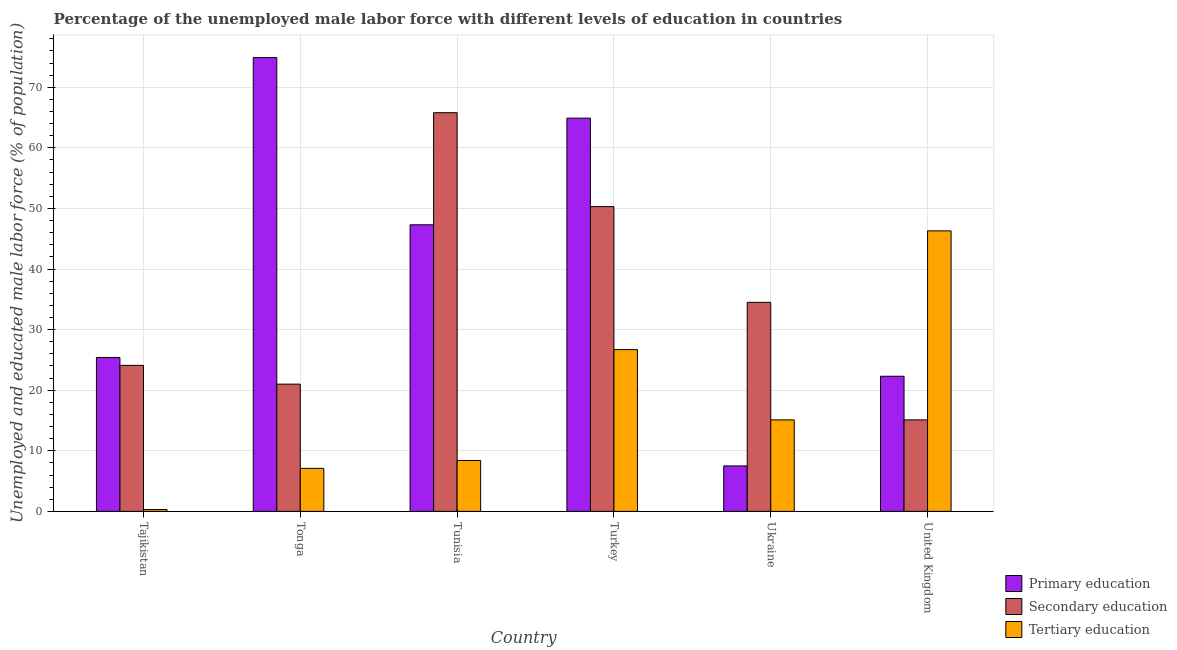How many groups of bars are there?
Your answer should be very brief. 6. Are the number of bars per tick equal to the number of legend labels?
Offer a very short reply. Yes. What is the label of the 4th group of bars from the left?
Ensure brevity in your answer.  Turkey. What is the percentage of male labor force who received primary education in Turkey?
Provide a succinct answer. 64.9. Across all countries, what is the maximum percentage of male labor force who received primary education?
Ensure brevity in your answer.  74.9. Across all countries, what is the minimum percentage of male labor force who received secondary education?
Offer a very short reply. 15.1. In which country was the percentage of male labor force who received tertiary education maximum?
Give a very brief answer. United Kingdom. In which country was the percentage of male labor force who received primary education minimum?
Ensure brevity in your answer.  Ukraine. What is the total percentage of male labor force who received primary education in the graph?
Provide a succinct answer. 242.3. What is the difference between the percentage of male labor force who received primary education in Tonga and that in United Kingdom?
Your answer should be compact. 52.6. What is the difference between the percentage of male labor force who received secondary education in Tunisia and the percentage of male labor force who received primary education in Tonga?
Provide a short and direct response. -9.1. What is the average percentage of male labor force who received primary education per country?
Provide a short and direct response. 40.38. What is the difference between the percentage of male labor force who received tertiary education and percentage of male labor force who received secondary education in Tonga?
Your answer should be very brief. -13.9. In how many countries, is the percentage of male labor force who received primary education greater than 2 %?
Provide a short and direct response. 6. What is the ratio of the percentage of male labor force who received secondary education in Tajikistan to that in Tunisia?
Your answer should be very brief. 0.37. Is the difference between the percentage of male labor force who received primary education in Turkey and United Kingdom greater than the difference between the percentage of male labor force who received tertiary education in Turkey and United Kingdom?
Offer a very short reply. Yes. What is the difference between the highest and the second highest percentage of male labor force who received tertiary education?
Your response must be concise. 19.6. What is the difference between the highest and the lowest percentage of male labor force who received secondary education?
Your answer should be very brief. 50.7. In how many countries, is the percentage of male labor force who received secondary education greater than the average percentage of male labor force who received secondary education taken over all countries?
Your response must be concise. 2. Is the sum of the percentage of male labor force who received secondary education in Tajikistan and Turkey greater than the maximum percentage of male labor force who received primary education across all countries?
Your answer should be compact. No. What does the 3rd bar from the left in Ukraine represents?
Your response must be concise. Tertiary education. Is it the case that in every country, the sum of the percentage of male labor force who received primary education and percentage of male labor force who received secondary education is greater than the percentage of male labor force who received tertiary education?
Ensure brevity in your answer.  No. How many bars are there?
Make the answer very short. 18. How many countries are there in the graph?
Ensure brevity in your answer.  6. Are the values on the major ticks of Y-axis written in scientific E-notation?
Provide a succinct answer. No. Does the graph contain any zero values?
Ensure brevity in your answer.  No. Where does the legend appear in the graph?
Your answer should be compact. Bottom right. How many legend labels are there?
Give a very brief answer. 3. What is the title of the graph?
Keep it short and to the point. Percentage of the unemployed male labor force with different levels of education in countries. Does "Manufactures" appear as one of the legend labels in the graph?
Offer a terse response. No. What is the label or title of the Y-axis?
Provide a short and direct response. Unemployed and educated male labor force (% of population). What is the Unemployed and educated male labor force (% of population) in Primary education in Tajikistan?
Make the answer very short. 25.4. What is the Unemployed and educated male labor force (% of population) in Secondary education in Tajikistan?
Ensure brevity in your answer.  24.1. What is the Unemployed and educated male labor force (% of population) of Tertiary education in Tajikistan?
Offer a terse response. 0.3. What is the Unemployed and educated male labor force (% of population) of Primary education in Tonga?
Make the answer very short. 74.9. What is the Unemployed and educated male labor force (% of population) in Secondary education in Tonga?
Ensure brevity in your answer.  21. What is the Unemployed and educated male labor force (% of population) of Tertiary education in Tonga?
Offer a very short reply. 7.1. What is the Unemployed and educated male labor force (% of population) in Primary education in Tunisia?
Make the answer very short. 47.3. What is the Unemployed and educated male labor force (% of population) of Secondary education in Tunisia?
Give a very brief answer. 65.8. What is the Unemployed and educated male labor force (% of population) in Tertiary education in Tunisia?
Your response must be concise. 8.4. What is the Unemployed and educated male labor force (% of population) of Primary education in Turkey?
Your response must be concise. 64.9. What is the Unemployed and educated male labor force (% of population) in Secondary education in Turkey?
Ensure brevity in your answer.  50.3. What is the Unemployed and educated male labor force (% of population) of Tertiary education in Turkey?
Your answer should be compact. 26.7. What is the Unemployed and educated male labor force (% of population) of Secondary education in Ukraine?
Make the answer very short. 34.5. What is the Unemployed and educated male labor force (% of population) in Tertiary education in Ukraine?
Your answer should be compact. 15.1. What is the Unemployed and educated male labor force (% of population) of Primary education in United Kingdom?
Your answer should be very brief. 22.3. What is the Unemployed and educated male labor force (% of population) in Secondary education in United Kingdom?
Your answer should be very brief. 15.1. What is the Unemployed and educated male labor force (% of population) of Tertiary education in United Kingdom?
Your answer should be very brief. 46.3. Across all countries, what is the maximum Unemployed and educated male labor force (% of population) of Primary education?
Ensure brevity in your answer.  74.9. Across all countries, what is the maximum Unemployed and educated male labor force (% of population) in Secondary education?
Your answer should be very brief. 65.8. Across all countries, what is the maximum Unemployed and educated male labor force (% of population) in Tertiary education?
Provide a succinct answer. 46.3. Across all countries, what is the minimum Unemployed and educated male labor force (% of population) of Secondary education?
Offer a very short reply. 15.1. Across all countries, what is the minimum Unemployed and educated male labor force (% of population) of Tertiary education?
Give a very brief answer. 0.3. What is the total Unemployed and educated male labor force (% of population) in Primary education in the graph?
Your response must be concise. 242.3. What is the total Unemployed and educated male labor force (% of population) in Secondary education in the graph?
Keep it short and to the point. 210.8. What is the total Unemployed and educated male labor force (% of population) in Tertiary education in the graph?
Make the answer very short. 103.9. What is the difference between the Unemployed and educated male labor force (% of population) of Primary education in Tajikistan and that in Tonga?
Offer a terse response. -49.5. What is the difference between the Unemployed and educated male labor force (% of population) of Tertiary education in Tajikistan and that in Tonga?
Keep it short and to the point. -6.8. What is the difference between the Unemployed and educated male labor force (% of population) in Primary education in Tajikistan and that in Tunisia?
Offer a terse response. -21.9. What is the difference between the Unemployed and educated male labor force (% of population) in Secondary education in Tajikistan and that in Tunisia?
Offer a terse response. -41.7. What is the difference between the Unemployed and educated male labor force (% of population) in Primary education in Tajikistan and that in Turkey?
Offer a terse response. -39.5. What is the difference between the Unemployed and educated male labor force (% of population) of Secondary education in Tajikistan and that in Turkey?
Provide a succinct answer. -26.2. What is the difference between the Unemployed and educated male labor force (% of population) of Tertiary education in Tajikistan and that in Turkey?
Offer a very short reply. -26.4. What is the difference between the Unemployed and educated male labor force (% of population) of Primary education in Tajikistan and that in Ukraine?
Offer a terse response. 17.9. What is the difference between the Unemployed and educated male labor force (% of population) in Tertiary education in Tajikistan and that in Ukraine?
Your answer should be compact. -14.8. What is the difference between the Unemployed and educated male labor force (% of population) of Primary education in Tajikistan and that in United Kingdom?
Ensure brevity in your answer.  3.1. What is the difference between the Unemployed and educated male labor force (% of population) of Tertiary education in Tajikistan and that in United Kingdom?
Ensure brevity in your answer.  -46. What is the difference between the Unemployed and educated male labor force (% of population) in Primary education in Tonga and that in Tunisia?
Provide a short and direct response. 27.6. What is the difference between the Unemployed and educated male labor force (% of population) in Secondary education in Tonga and that in Tunisia?
Make the answer very short. -44.8. What is the difference between the Unemployed and educated male labor force (% of population) in Primary education in Tonga and that in Turkey?
Make the answer very short. 10. What is the difference between the Unemployed and educated male labor force (% of population) of Secondary education in Tonga and that in Turkey?
Give a very brief answer. -29.3. What is the difference between the Unemployed and educated male labor force (% of population) of Tertiary education in Tonga and that in Turkey?
Make the answer very short. -19.6. What is the difference between the Unemployed and educated male labor force (% of population) in Primary education in Tonga and that in Ukraine?
Give a very brief answer. 67.4. What is the difference between the Unemployed and educated male labor force (% of population) in Secondary education in Tonga and that in Ukraine?
Your answer should be very brief. -13.5. What is the difference between the Unemployed and educated male labor force (% of population) of Primary education in Tonga and that in United Kingdom?
Your answer should be compact. 52.6. What is the difference between the Unemployed and educated male labor force (% of population) in Tertiary education in Tonga and that in United Kingdom?
Your response must be concise. -39.2. What is the difference between the Unemployed and educated male labor force (% of population) in Primary education in Tunisia and that in Turkey?
Provide a short and direct response. -17.6. What is the difference between the Unemployed and educated male labor force (% of population) in Tertiary education in Tunisia and that in Turkey?
Offer a terse response. -18.3. What is the difference between the Unemployed and educated male labor force (% of population) in Primary education in Tunisia and that in Ukraine?
Keep it short and to the point. 39.8. What is the difference between the Unemployed and educated male labor force (% of population) in Secondary education in Tunisia and that in Ukraine?
Provide a short and direct response. 31.3. What is the difference between the Unemployed and educated male labor force (% of population) of Secondary education in Tunisia and that in United Kingdom?
Make the answer very short. 50.7. What is the difference between the Unemployed and educated male labor force (% of population) of Tertiary education in Tunisia and that in United Kingdom?
Offer a very short reply. -37.9. What is the difference between the Unemployed and educated male labor force (% of population) of Primary education in Turkey and that in Ukraine?
Your answer should be compact. 57.4. What is the difference between the Unemployed and educated male labor force (% of population) of Secondary education in Turkey and that in Ukraine?
Provide a short and direct response. 15.8. What is the difference between the Unemployed and educated male labor force (% of population) of Primary education in Turkey and that in United Kingdom?
Make the answer very short. 42.6. What is the difference between the Unemployed and educated male labor force (% of population) of Secondary education in Turkey and that in United Kingdom?
Keep it short and to the point. 35.2. What is the difference between the Unemployed and educated male labor force (% of population) in Tertiary education in Turkey and that in United Kingdom?
Keep it short and to the point. -19.6. What is the difference between the Unemployed and educated male labor force (% of population) of Primary education in Ukraine and that in United Kingdom?
Your answer should be very brief. -14.8. What is the difference between the Unemployed and educated male labor force (% of population) in Secondary education in Ukraine and that in United Kingdom?
Offer a terse response. 19.4. What is the difference between the Unemployed and educated male labor force (% of population) of Tertiary education in Ukraine and that in United Kingdom?
Your answer should be compact. -31.2. What is the difference between the Unemployed and educated male labor force (% of population) of Primary education in Tajikistan and the Unemployed and educated male labor force (% of population) of Secondary education in Tonga?
Your answer should be compact. 4.4. What is the difference between the Unemployed and educated male labor force (% of population) of Secondary education in Tajikistan and the Unemployed and educated male labor force (% of population) of Tertiary education in Tonga?
Provide a succinct answer. 17. What is the difference between the Unemployed and educated male labor force (% of population) of Primary education in Tajikistan and the Unemployed and educated male labor force (% of population) of Secondary education in Tunisia?
Offer a terse response. -40.4. What is the difference between the Unemployed and educated male labor force (% of population) of Primary education in Tajikistan and the Unemployed and educated male labor force (% of population) of Tertiary education in Tunisia?
Ensure brevity in your answer.  17. What is the difference between the Unemployed and educated male labor force (% of population) in Primary education in Tajikistan and the Unemployed and educated male labor force (% of population) in Secondary education in Turkey?
Make the answer very short. -24.9. What is the difference between the Unemployed and educated male labor force (% of population) in Primary education in Tajikistan and the Unemployed and educated male labor force (% of population) in Tertiary education in Turkey?
Provide a short and direct response. -1.3. What is the difference between the Unemployed and educated male labor force (% of population) in Primary education in Tajikistan and the Unemployed and educated male labor force (% of population) in Secondary education in Ukraine?
Your answer should be very brief. -9.1. What is the difference between the Unemployed and educated male labor force (% of population) in Primary education in Tajikistan and the Unemployed and educated male labor force (% of population) in Tertiary education in United Kingdom?
Your answer should be compact. -20.9. What is the difference between the Unemployed and educated male labor force (% of population) of Secondary education in Tajikistan and the Unemployed and educated male labor force (% of population) of Tertiary education in United Kingdom?
Your answer should be very brief. -22.2. What is the difference between the Unemployed and educated male labor force (% of population) of Primary education in Tonga and the Unemployed and educated male labor force (% of population) of Secondary education in Tunisia?
Offer a very short reply. 9.1. What is the difference between the Unemployed and educated male labor force (% of population) in Primary education in Tonga and the Unemployed and educated male labor force (% of population) in Tertiary education in Tunisia?
Your answer should be very brief. 66.5. What is the difference between the Unemployed and educated male labor force (% of population) in Primary education in Tonga and the Unemployed and educated male labor force (% of population) in Secondary education in Turkey?
Your answer should be very brief. 24.6. What is the difference between the Unemployed and educated male labor force (% of population) of Primary education in Tonga and the Unemployed and educated male labor force (% of population) of Tertiary education in Turkey?
Ensure brevity in your answer.  48.2. What is the difference between the Unemployed and educated male labor force (% of population) of Primary education in Tonga and the Unemployed and educated male labor force (% of population) of Secondary education in Ukraine?
Offer a terse response. 40.4. What is the difference between the Unemployed and educated male labor force (% of population) of Primary education in Tonga and the Unemployed and educated male labor force (% of population) of Tertiary education in Ukraine?
Keep it short and to the point. 59.8. What is the difference between the Unemployed and educated male labor force (% of population) in Primary education in Tonga and the Unemployed and educated male labor force (% of population) in Secondary education in United Kingdom?
Keep it short and to the point. 59.8. What is the difference between the Unemployed and educated male labor force (% of population) in Primary education in Tonga and the Unemployed and educated male labor force (% of population) in Tertiary education in United Kingdom?
Provide a succinct answer. 28.6. What is the difference between the Unemployed and educated male labor force (% of population) of Secondary education in Tonga and the Unemployed and educated male labor force (% of population) of Tertiary education in United Kingdom?
Your answer should be very brief. -25.3. What is the difference between the Unemployed and educated male labor force (% of population) in Primary education in Tunisia and the Unemployed and educated male labor force (% of population) in Tertiary education in Turkey?
Provide a succinct answer. 20.6. What is the difference between the Unemployed and educated male labor force (% of population) of Secondary education in Tunisia and the Unemployed and educated male labor force (% of population) of Tertiary education in Turkey?
Your answer should be very brief. 39.1. What is the difference between the Unemployed and educated male labor force (% of population) of Primary education in Tunisia and the Unemployed and educated male labor force (% of population) of Tertiary education in Ukraine?
Ensure brevity in your answer.  32.2. What is the difference between the Unemployed and educated male labor force (% of population) in Secondary education in Tunisia and the Unemployed and educated male labor force (% of population) in Tertiary education in Ukraine?
Your answer should be compact. 50.7. What is the difference between the Unemployed and educated male labor force (% of population) of Primary education in Tunisia and the Unemployed and educated male labor force (% of population) of Secondary education in United Kingdom?
Offer a very short reply. 32.2. What is the difference between the Unemployed and educated male labor force (% of population) in Primary education in Tunisia and the Unemployed and educated male labor force (% of population) in Tertiary education in United Kingdom?
Your response must be concise. 1. What is the difference between the Unemployed and educated male labor force (% of population) of Primary education in Turkey and the Unemployed and educated male labor force (% of population) of Secondary education in Ukraine?
Ensure brevity in your answer.  30.4. What is the difference between the Unemployed and educated male labor force (% of population) in Primary education in Turkey and the Unemployed and educated male labor force (% of population) in Tertiary education in Ukraine?
Provide a succinct answer. 49.8. What is the difference between the Unemployed and educated male labor force (% of population) of Secondary education in Turkey and the Unemployed and educated male labor force (% of population) of Tertiary education in Ukraine?
Provide a succinct answer. 35.2. What is the difference between the Unemployed and educated male labor force (% of population) in Primary education in Turkey and the Unemployed and educated male labor force (% of population) in Secondary education in United Kingdom?
Make the answer very short. 49.8. What is the difference between the Unemployed and educated male labor force (% of population) of Primary education in Turkey and the Unemployed and educated male labor force (% of population) of Tertiary education in United Kingdom?
Your response must be concise. 18.6. What is the difference between the Unemployed and educated male labor force (% of population) of Primary education in Ukraine and the Unemployed and educated male labor force (% of population) of Secondary education in United Kingdom?
Give a very brief answer. -7.6. What is the difference between the Unemployed and educated male labor force (% of population) in Primary education in Ukraine and the Unemployed and educated male labor force (% of population) in Tertiary education in United Kingdom?
Your response must be concise. -38.8. What is the difference between the Unemployed and educated male labor force (% of population) in Secondary education in Ukraine and the Unemployed and educated male labor force (% of population) in Tertiary education in United Kingdom?
Your answer should be compact. -11.8. What is the average Unemployed and educated male labor force (% of population) of Primary education per country?
Make the answer very short. 40.38. What is the average Unemployed and educated male labor force (% of population) in Secondary education per country?
Offer a very short reply. 35.13. What is the average Unemployed and educated male labor force (% of population) of Tertiary education per country?
Give a very brief answer. 17.32. What is the difference between the Unemployed and educated male labor force (% of population) of Primary education and Unemployed and educated male labor force (% of population) of Tertiary education in Tajikistan?
Your response must be concise. 25.1. What is the difference between the Unemployed and educated male labor force (% of population) in Secondary education and Unemployed and educated male labor force (% of population) in Tertiary education in Tajikistan?
Your answer should be very brief. 23.8. What is the difference between the Unemployed and educated male labor force (% of population) of Primary education and Unemployed and educated male labor force (% of population) of Secondary education in Tonga?
Give a very brief answer. 53.9. What is the difference between the Unemployed and educated male labor force (% of population) in Primary education and Unemployed and educated male labor force (% of population) in Tertiary education in Tonga?
Your answer should be very brief. 67.8. What is the difference between the Unemployed and educated male labor force (% of population) in Secondary education and Unemployed and educated male labor force (% of population) in Tertiary education in Tonga?
Your answer should be very brief. 13.9. What is the difference between the Unemployed and educated male labor force (% of population) of Primary education and Unemployed and educated male labor force (% of population) of Secondary education in Tunisia?
Offer a terse response. -18.5. What is the difference between the Unemployed and educated male labor force (% of population) of Primary education and Unemployed and educated male labor force (% of population) of Tertiary education in Tunisia?
Provide a succinct answer. 38.9. What is the difference between the Unemployed and educated male labor force (% of population) of Secondary education and Unemployed and educated male labor force (% of population) of Tertiary education in Tunisia?
Keep it short and to the point. 57.4. What is the difference between the Unemployed and educated male labor force (% of population) of Primary education and Unemployed and educated male labor force (% of population) of Tertiary education in Turkey?
Offer a very short reply. 38.2. What is the difference between the Unemployed and educated male labor force (% of population) of Secondary education and Unemployed and educated male labor force (% of population) of Tertiary education in Turkey?
Provide a short and direct response. 23.6. What is the difference between the Unemployed and educated male labor force (% of population) in Primary education and Unemployed and educated male labor force (% of population) in Tertiary education in Ukraine?
Keep it short and to the point. -7.6. What is the difference between the Unemployed and educated male labor force (% of population) of Primary education and Unemployed and educated male labor force (% of population) of Secondary education in United Kingdom?
Your answer should be compact. 7.2. What is the difference between the Unemployed and educated male labor force (% of population) of Secondary education and Unemployed and educated male labor force (% of population) of Tertiary education in United Kingdom?
Give a very brief answer. -31.2. What is the ratio of the Unemployed and educated male labor force (% of population) in Primary education in Tajikistan to that in Tonga?
Offer a very short reply. 0.34. What is the ratio of the Unemployed and educated male labor force (% of population) of Secondary education in Tajikistan to that in Tonga?
Your answer should be very brief. 1.15. What is the ratio of the Unemployed and educated male labor force (% of population) in Tertiary education in Tajikistan to that in Tonga?
Offer a terse response. 0.04. What is the ratio of the Unemployed and educated male labor force (% of population) of Primary education in Tajikistan to that in Tunisia?
Ensure brevity in your answer.  0.54. What is the ratio of the Unemployed and educated male labor force (% of population) of Secondary education in Tajikistan to that in Tunisia?
Offer a very short reply. 0.37. What is the ratio of the Unemployed and educated male labor force (% of population) in Tertiary education in Tajikistan to that in Tunisia?
Offer a terse response. 0.04. What is the ratio of the Unemployed and educated male labor force (% of population) of Primary education in Tajikistan to that in Turkey?
Your answer should be very brief. 0.39. What is the ratio of the Unemployed and educated male labor force (% of population) in Secondary education in Tajikistan to that in Turkey?
Your answer should be very brief. 0.48. What is the ratio of the Unemployed and educated male labor force (% of population) of Tertiary education in Tajikistan to that in Turkey?
Ensure brevity in your answer.  0.01. What is the ratio of the Unemployed and educated male labor force (% of population) of Primary education in Tajikistan to that in Ukraine?
Offer a terse response. 3.39. What is the ratio of the Unemployed and educated male labor force (% of population) of Secondary education in Tajikistan to that in Ukraine?
Give a very brief answer. 0.7. What is the ratio of the Unemployed and educated male labor force (% of population) of Tertiary education in Tajikistan to that in Ukraine?
Offer a terse response. 0.02. What is the ratio of the Unemployed and educated male labor force (% of population) of Primary education in Tajikistan to that in United Kingdom?
Give a very brief answer. 1.14. What is the ratio of the Unemployed and educated male labor force (% of population) in Secondary education in Tajikistan to that in United Kingdom?
Offer a very short reply. 1.6. What is the ratio of the Unemployed and educated male labor force (% of population) in Tertiary education in Tajikistan to that in United Kingdom?
Your response must be concise. 0.01. What is the ratio of the Unemployed and educated male labor force (% of population) of Primary education in Tonga to that in Tunisia?
Provide a short and direct response. 1.58. What is the ratio of the Unemployed and educated male labor force (% of population) of Secondary education in Tonga to that in Tunisia?
Give a very brief answer. 0.32. What is the ratio of the Unemployed and educated male labor force (% of population) of Tertiary education in Tonga to that in Tunisia?
Make the answer very short. 0.85. What is the ratio of the Unemployed and educated male labor force (% of population) of Primary education in Tonga to that in Turkey?
Ensure brevity in your answer.  1.15. What is the ratio of the Unemployed and educated male labor force (% of population) of Secondary education in Tonga to that in Turkey?
Ensure brevity in your answer.  0.42. What is the ratio of the Unemployed and educated male labor force (% of population) of Tertiary education in Tonga to that in Turkey?
Your answer should be compact. 0.27. What is the ratio of the Unemployed and educated male labor force (% of population) of Primary education in Tonga to that in Ukraine?
Make the answer very short. 9.99. What is the ratio of the Unemployed and educated male labor force (% of population) of Secondary education in Tonga to that in Ukraine?
Provide a short and direct response. 0.61. What is the ratio of the Unemployed and educated male labor force (% of population) in Tertiary education in Tonga to that in Ukraine?
Offer a terse response. 0.47. What is the ratio of the Unemployed and educated male labor force (% of population) of Primary education in Tonga to that in United Kingdom?
Your answer should be compact. 3.36. What is the ratio of the Unemployed and educated male labor force (% of population) of Secondary education in Tonga to that in United Kingdom?
Offer a terse response. 1.39. What is the ratio of the Unemployed and educated male labor force (% of population) of Tertiary education in Tonga to that in United Kingdom?
Keep it short and to the point. 0.15. What is the ratio of the Unemployed and educated male labor force (% of population) in Primary education in Tunisia to that in Turkey?
Make the answer very short. 0.73. What is the ratio of the Unemployed and educated male labor force (% of population) in Secondary education in Tunisia to that in Turkey?
Offer a terse response. 1.31. What is the ratio of the Unemployed and educated male labor force (% of population) of Tertiary education in Tunisia to that in Turkey?
Your answer should be very brief. 0.31. What is the ratio of the Unemployed and educated male labor force (% of population) of Primary education in Tunisia to that in Ukraine?
Your answer should be compact. 6.31. What is the ratio of the Unemployed and educated male labor force (% of population) of Secondary education in Tunisia to that in Ukraine?
Your answer should be compact. 1.91. What is the ratio of the Unemployed and educated male labor force (% of population) of Tertiary education in Tunisia to that in Ukraine?
Give a very brief answer. 0.56. What is the ratio of the Unemployed and educated male labor force (% of population) in Primary education in Tunisia to that in United Kingdom?
Offer a very short reply. 2.12. What is the ratio of the Unemployed and educated male labor force (% of population) in Secondary education in Tunisia to that in United Kingdom?
Your response must be concise. 4.36. What is the ratio of the Unemployed and educated male labor force (% of population) of Tertiary education in Tunisia to that in United Kingdom?
Offer a very short reply. 0.18. What is the ratio of the Unemployed and educated male labor force (% of population) in Primary education in Turkey to that in Ukraine?
Provide a succinct answer. 8.65. What is the ratio of the Unemployed and educated male labor force (% of population) in Secondary education in Turkey to that in Ukraine?
Offer a very short reply. 1.46. What is the ratio of the Unemployed and educated male labor force (% of population) of Tertiary education in Turkey to that in Ukraine?
Give a very brief answer. 1.77. What is the ratio of the Unemployed and educated male labor force (% of population) of Primary education in Turkey to that in United Kingdom?
Make the answer very short. 2.91. What is the ratio of the Unemployed and educated male labor force (% of population) in Secondary education in Turkey to that in United Kingdom?
Ensure brevity in your answer.  3.33. What is the ratio of the Unemployed and educated male labor force (% of population) in Tertiary education in Turkey to that in United Kingdom?
Offer a very short reply. 0.58. What is the ratio of the Unemployed and educated male labor force (% of population) of Primary education in Ukraine to that in United Kingdom?
Make the answer very short. 0.34. What is the ratio of the Unemployed and educated male labor force (% of population) in Secondary education in Ukraine to that in United Kingdom?
Your answer should be compact. 2.28. What is the ratio of the Unemployed and educated male labor force (% of population) in Tertiary education in Ukraine to that in United Kingdom?
Provide a succinct answer. 0.33. What is the difference between the highest and the second highest Unemployed and educated male labor force (% of population) of Primary education?
Offer a terse response. 10. What is the difference between the highest and the second highest Unemployed and educated male labor force (% of population) of Secondary education?
Make the answer very short. 15.5. What is the difference between the highest and the second highest Unemployed and educated male labor force (% of population) of Tertiary education?
Make the answer very short. 19.6. What is the difference between the highest and the lowest Unemployed and educated male labor force (% of population) of Primary education?
Ensure brevity in your answer.  67.4. What is the difference between the highest and the lowest Unemployed and educated male labor force (% of population) of Secondary education?
Offer a terse response. 50.7. What is the difference between the highest and the lowest Unemployed and educated male labor force (% of population) of Tertiary education?
Provide a succinct answer. 46. 